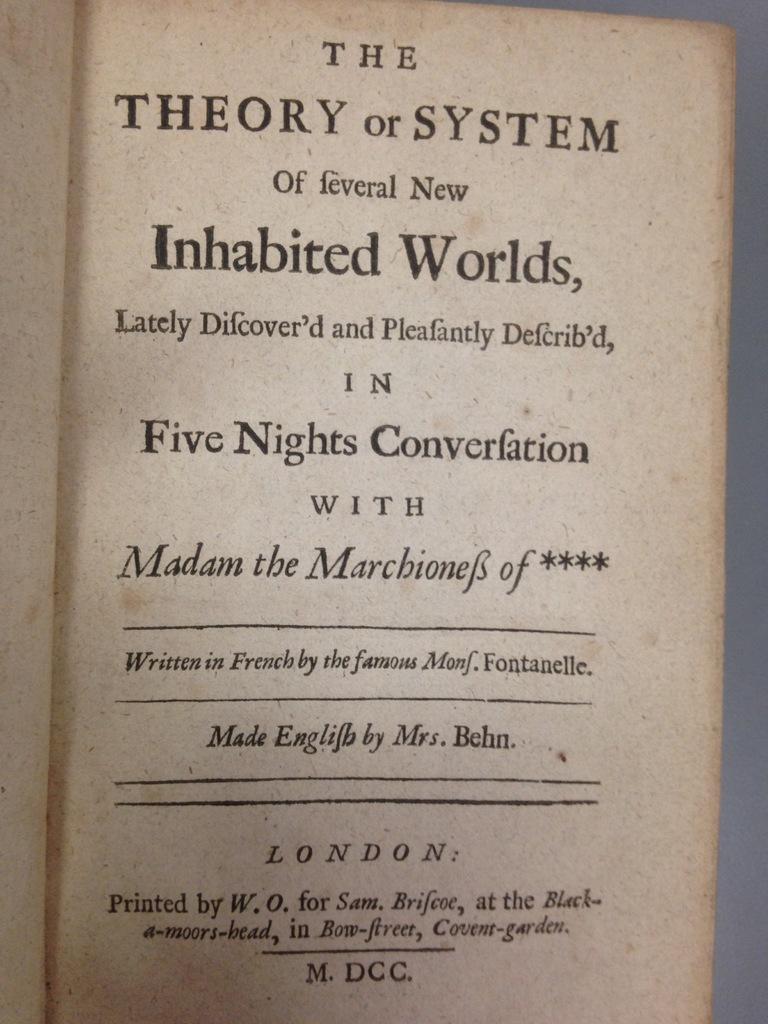What's the title of this book?
Offer a terse response. The theory or system of several new inhabited worlds. 